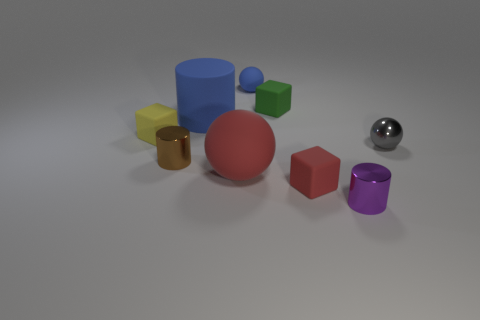What might be the size relationship between the objects? The objects appear to be arranged in a way that suggests a variety of sizes. The blue cylinder and the red ball look to be the largest objects in the scene, followed by the purple cylinder and the gold cube which appear moderately sized. The small green cube and the silver ball seem to be the smallest. 